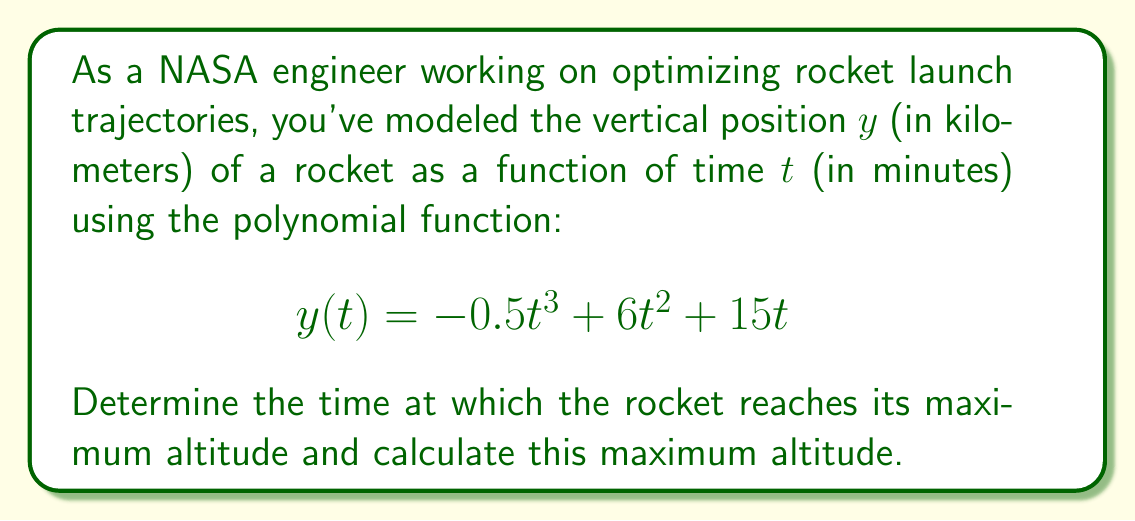Help me with this question. To solve this problem, we'll follow these steps:

1) The maximum altitude occurs when the vertical velocity is zero. The vertical velocity is given by the first derivative of the position function.

2) Find the first derivative of $y(t)$:
   $$y'(t) = -1.5t^2 + 12t + 15$$

3) Set $y'(t) = 0$ and solve for $t$:
   $$-1.5t^2 + 12t + 15 = 0$$

4) This is a quadratic equation. We can solve it using the quadratic formula:
   $$t = \frac{-b \pm \sqrt{b^2 - 4ac}}{2a}$$
   where $a = -1.5$, $b = 12$, and $c = 15$

5) Substituting these values:
   $$t = \frac{-12 \pm \sqrt{12^2 - 4(-1.5)(15)}}{2(-1.5)}$$
   $$= \frac{-12 \pm \sqrt{144 + 90}}{-3}$$
   $$= \frac{-12 \pm \sqrt{234}}{-3}$$

6) Simplifying:
   $$t = \frac{12 \pm \sqrt{234}}{3}$$

7) This gives us two solutions: $t_1 \approx 8.77$ and $t_2 \approx 1.23$

8) The larger value (8.77 minutes) corresponds to the maximum altitude.

9) To find the maximum altitude, substitute $t = 8.77$ into the original function:
   $$y(8.77) = -0.5(8.77)^3 + 6(8.77)^2 + 15(8.77)$$
   $$\approx 180.42$$

Therefore, the rocket reaches its maximum altitude of approximately 180.42 km after 8.77 minutes.
Answer: Maximum altitude: 180.42 km at t = 8.77 minutes 